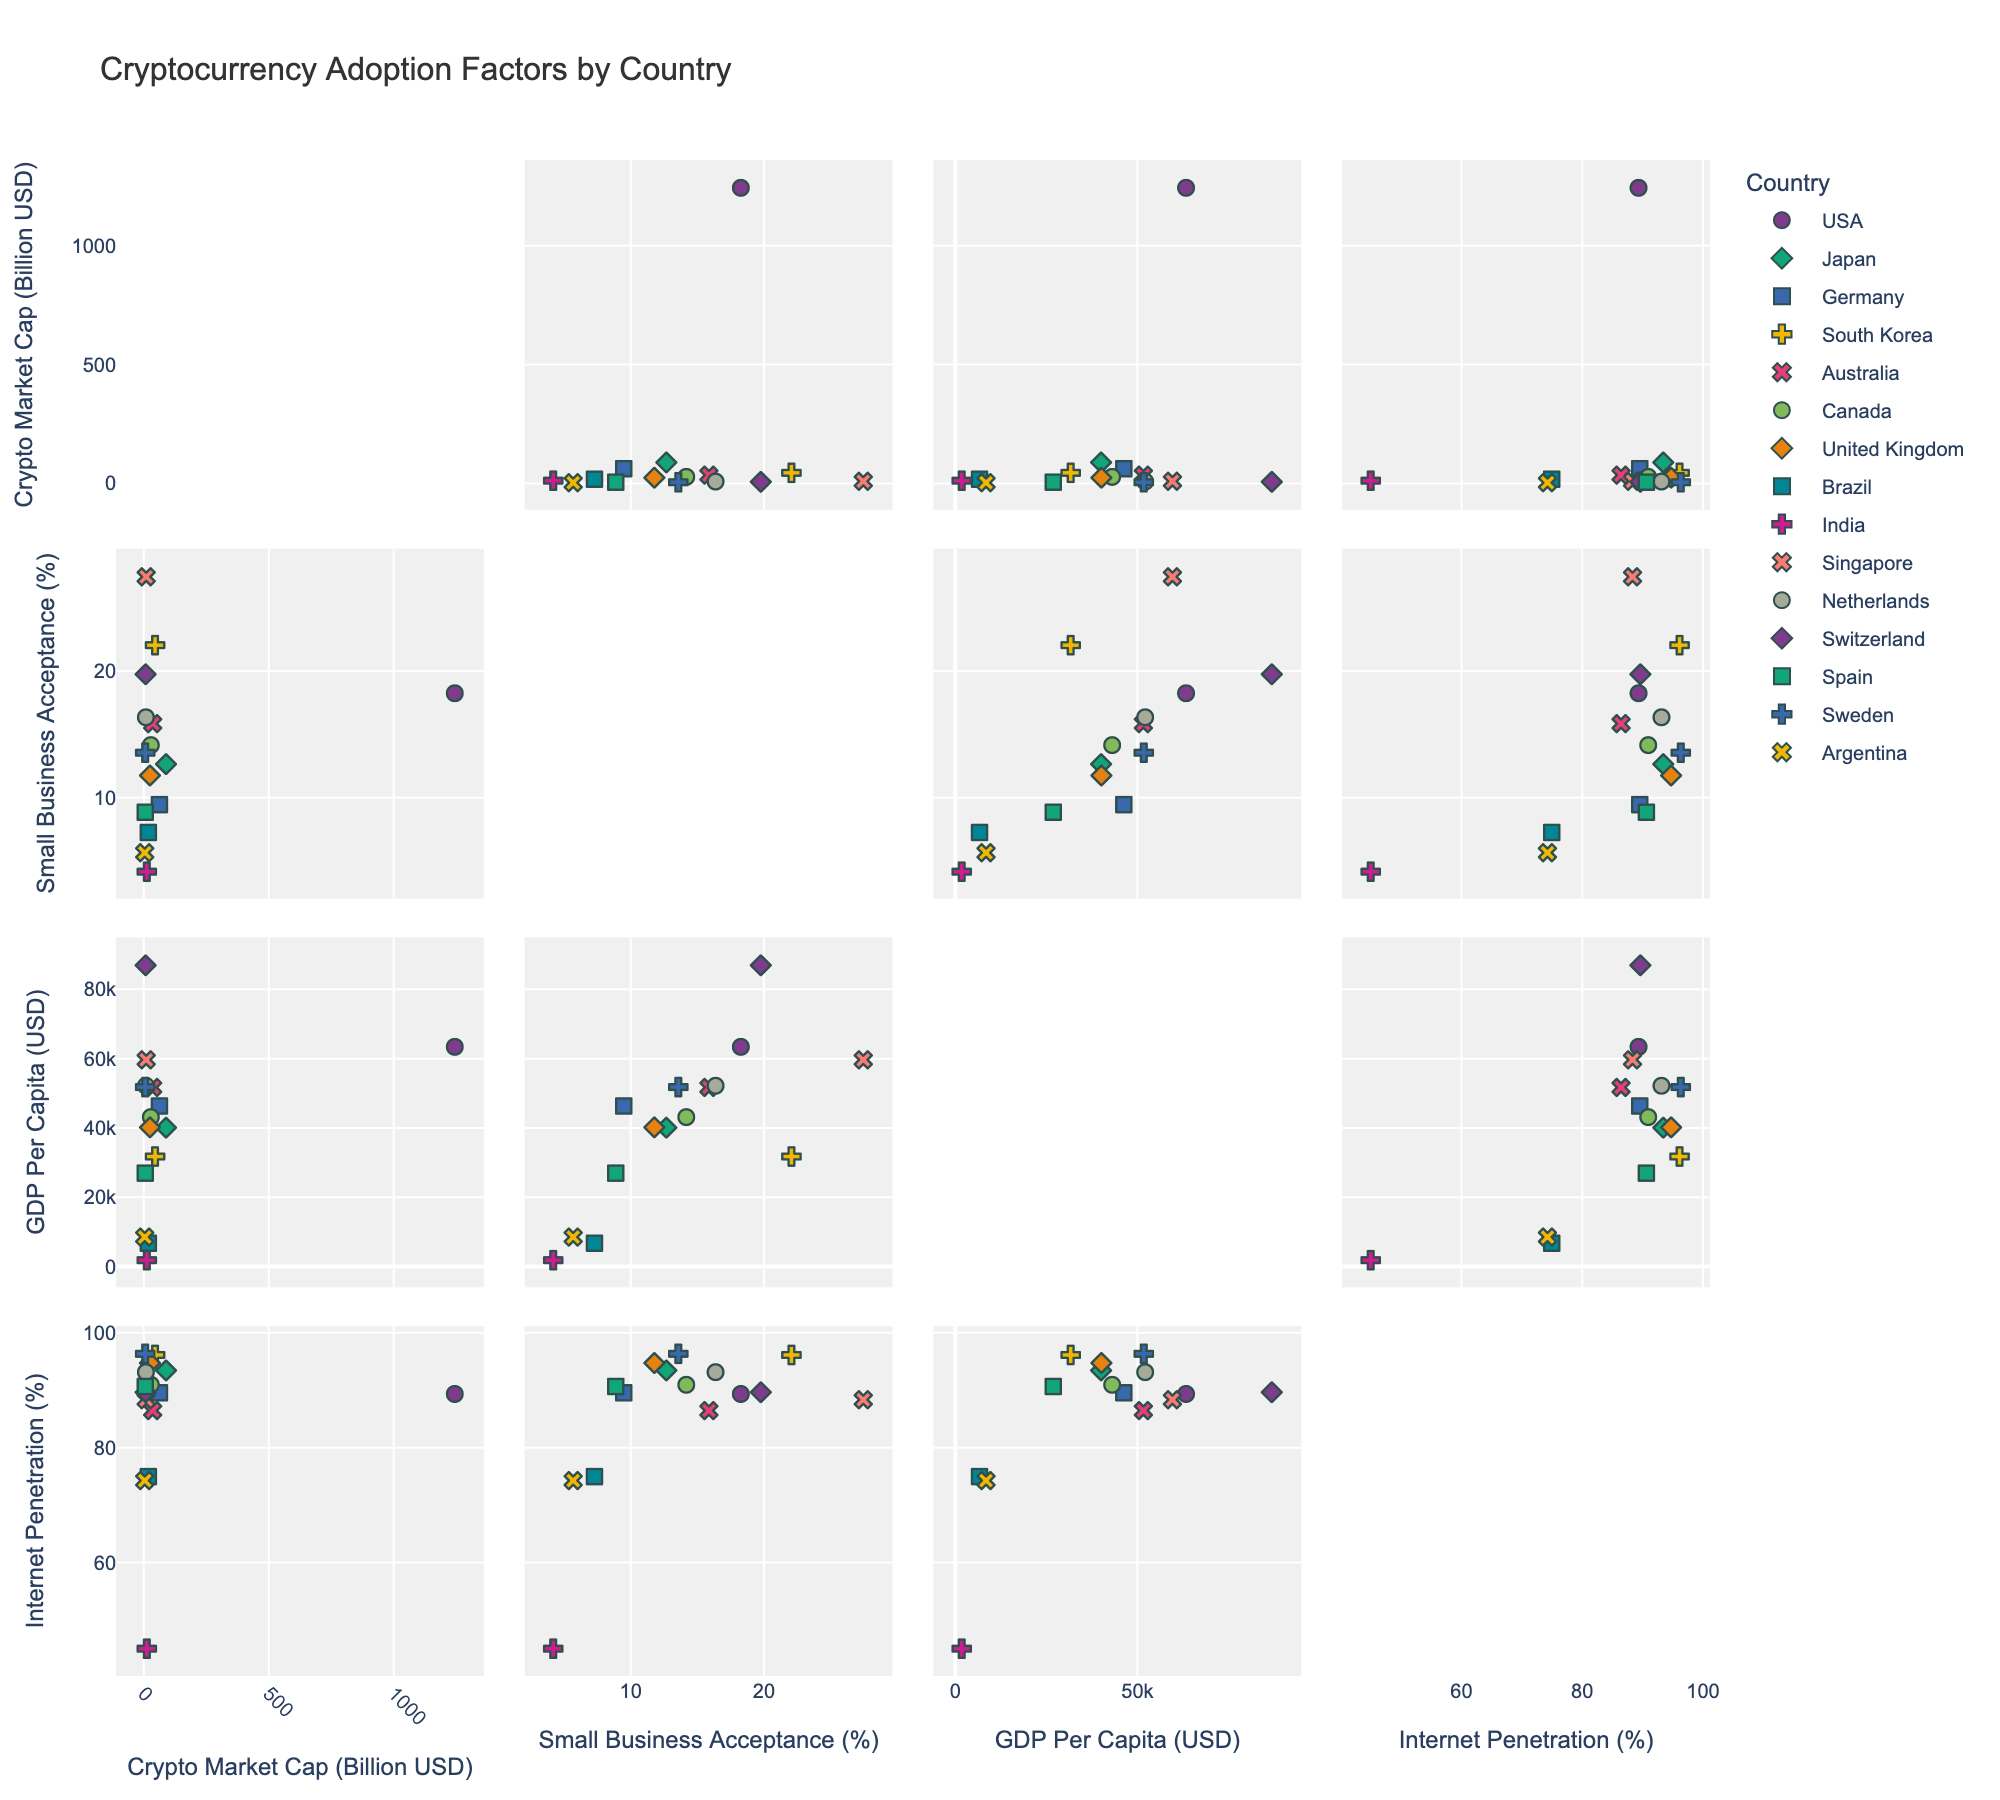What is the title of the figure? The title is located at the top of the plot and is intended to give an overview of what the figure represents. By checking the title, users can quickly understand the broader context.
Answer: Cryptocurrency Adoption Factors by Country Which country has the highest small business acceptance rate? Look at the y-axis labeled "Small Business Acceptance (%)" and identify the country with the highest point value.
Answer: Singapore How many countries have a small business acceptance rate above 15%? Check the y-axis labeled "Small Business Acceptance (%)" and count the number of data points that are above 15%.
Answer: 6 What is the relationship between cryptocurrency market capitalization and small business acceptance rate for the USA? Locate the data points for the USA and compare the values on the x-axis (Crypto Market Cap) and y-axis (Small Business Acceptance Rate).
Answer: High market cap, moderate acceptance rate Which country has the lowest GDP per capita, and what is its small business acceptance rate? Identify the country with the lowest position on the GDP per capita axis and note its corresponding small business acceptance rate value.
Answer: India, 4.2% Does higher internet penetration correspond to higher small business acceptance rates globally? Compare the scatter plot points on the x-axis labeled "Internet Penetration (%)" with the y-axis labeled "Small Business Acceptance (%)". Look for a general trend.
Answer: Mixed trend What is the GDP per capita of the country with a 19.8% small business acceptance rate? Find the point corresponding to a y-axis value of 19.8% and read its GDP per capita from the x-axis.
Answer: 87097 USD Which countries have both high cryptocurrency market caps and high internet penetration? Look for countries that have points towards the higher end of both "Crypto Market Cap" and "Internet Penetration" axes.
Answer: USA, Japan, South Korea How does the small business acceptance rate of Germany compare to Brazil? Identify the points corresponding to Germany and Brazil and compare their y-axis values labeled "Small Business Acceptance (%)".
Answer: Germany: 9.5%, Brazil: 7.3% What is the average internet penetration rate for countries with a small business acceptance rate above 20%? Identify countries with a small business acceptance rate above 20%, then calculate the average of their internet penetration rates.
Answer: (96.2 + 88.4) / 2 = 92.3% 